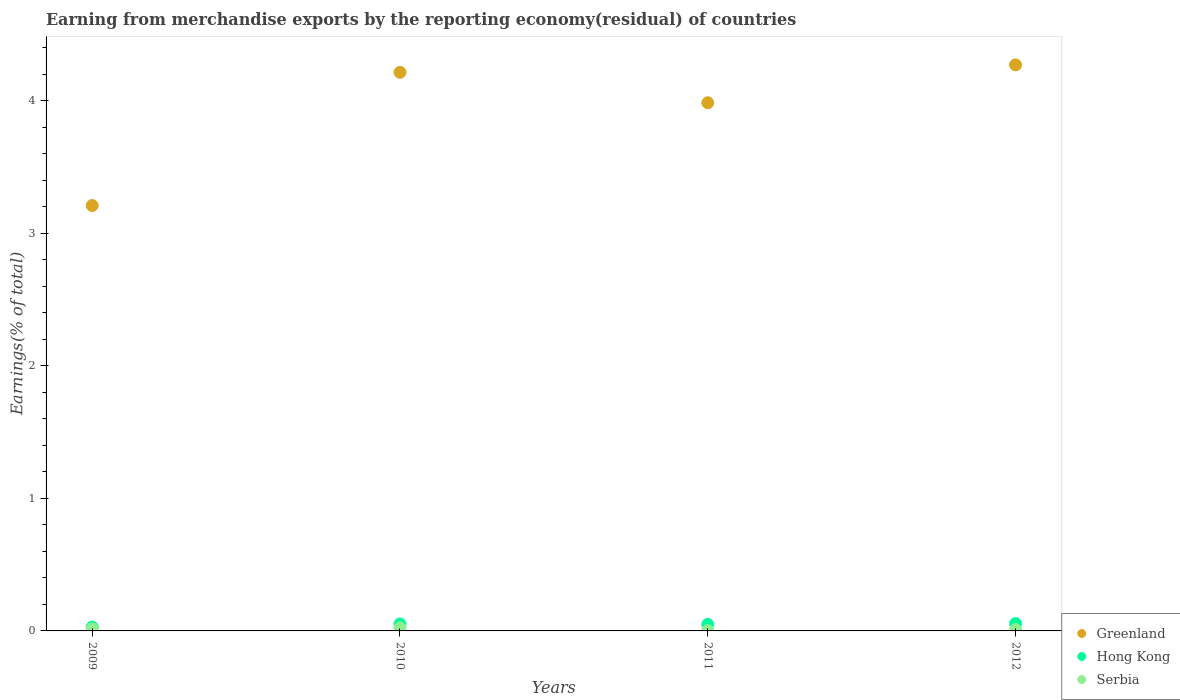How many different coloured dotlines are there?
Provide a short and direct response. 3. What is the percentage of amount earned from merchandise exports in Greenland in 2009?
Provide a short and direct response. 3.21. Across all years, what is the maximum percentage of amount earned from merchandise exports in Hong Kong?
Ensure brevity in your answer.  0.06. Across all years, what is the minimum percentage of amount earned from merchandise exports in Hong Kong?
Offer a terse response. 0.03. In which year was the percentage of amount earned from merchandise exports in Serbia minimum?
Your response must be concise. 2011. What is the total percentage of amount earned from merchandise exports in Serbia in the graph?
Ensure brevity in your answer.  0.05. What is the difference between the percentage of amount earned from merchandise exports in Greenland in 2010 and that in 2011?
Make the answer very short. 0.23. What is the difference between the percentage of amount earned from merchandise exports in Greenland in 2009 and the percentage of amount earned from merchandise exports in Serbia in 2012?
Ensure brevity in your answer.  3.2. What is the average percentage of amount earned from merchandise exports in Hong Kong per year?
Your answer should be compact. 0.05. In the year 2010, what is the difference between the percentage of amount earned from merchandise exports in Hong Kong and percentage of amount earned from merchandise exports in Greenland?
Keep it short and to the point. -4.16. In how many years, is the percentage of amount earned from merchandise exports in Hong Kong greater than 3.8 %?
Provide a succinct answer. 0. What is the ratio of the percentage of amount earned from merchandise exports in Hong Kong in 2010 to that in 2011?
Give a very brief answer. 1.07. What is the difference between the highest and the second highest percentage of amount earned from merchandise exports in Hong Kong?
Your answer should be very brief. 0. What is the difference between the highest and the lowest percentage of amount earned from merchandise exports in Greenland?
Provide a short and direct response. 1.06. In how many years, is the percentage of amount earned from merchandise exports in Hong Kong greater than the average percentage of amount earned from merchandise exports in Hong Kong taken over all years?
Keep it short and to the point. 3. Is the percentage of amount earned from merchandise exports in Greenland strictly less than the percentage of amount earned from merchandise exports in Serbia over the years?
Ensure brevity in your answer.  No. How many dotlines are there?
Give a very brief answer. 3. How many years are there in the graph?
Your answer should be compact. 4. Where does the legend appear in the graph?
Provide a succinct answer. Bottom right. How many legend labels are there?
Ensure brevity in your answer.  3. How are the legend labels stacked?
Offer a terse response. Vertical. What is the title of the graph?
Offer a very short reply. Earning from merchandise exports by the reporting economy(residual) of countries. What is the label or title of the Y-axis?
Provide a succinct answer. Earnings(% of total). What is the Earnings(% of total) of Greenland in 2009?
Your answer should be very brief. 3.21. What is the Earnings(% of total) in Hong Kong in 2009?
Make the answer very short. 0.03. What is the Earnings(% of total) in Serbia in 2009?
Your answer should be compact. 0.02. What is the Earnings(% of total) of Greenland in 2010?
Provide a succinct answer. 4.21. What is the Earnings(% of total) of Hong Kong in 2010?
Your answer should be compact. 0.05. What is the Earnings(% of total) in Serbia in 2010?
Make the answer very short. 0.02. What is the Earnings(% of total) of Greenland in 2011?
Your answer should be very brief. 3.99. What is the Earnings(% of total) of Hong Kong in 2011?
Provide a short and direct response. 0.05. What is the Earnings(% of total) in Serbia in 2011?
Offer a very short reply. 0. What is the Earnings(% of total) in Greenland in 2012?
Keep it short and to the point. 4.27. What is the Earnings(% of total) of Hong Kong in 2012?
Provide a short and direct response. 0.06. What is the Earnings(% of total) in Serbia in 2012?
Provide a succinct answer. 0.01. Across all years, what is the maximum Earnings(% of total) in Greenland?
Your answer should be compact. 4.27. Across all years, what is the maximum Earnings(% of total) in Hong Kong?
Offer a very short reply. 0.06. Across all years, what is the maximum Earnings(% of total) of Serbia?
Keep it short and to the point. 0.02. Across all years, what is the minimum Earnings(% of total) of Greenland?
Your answer should be very brief. 3.21. Across all years, what is the minimum Earnings(% of total) in Hong Kong?
Offer a terse response. 0.03. Across all years, what is the minimum Earnings(% of total) in Serbia?
Keep it short and to the point. 0. What is the total Earnings(% of total) in Greenland in the graph?
Your response must be concise. 15.68. What is the total Earnings(% of total) in Hong Kong in the graph?
Make the answer very short. 0.19. What is the total Earnings(% of total) of Serbia in the graph?
Provide a short and direct response. 0.05. What is the difference between the Earnings(% of total) in Greenland in 2009 and that in 2010?
Give a very brief answer. -1. What is the difference between the Earnings(% of total) in Hong Kong in 2009 and that in 2010?
Make the answer very short. -0.02. What is the difference between the Earnings(% of total) in Serbia in 2009 and that in 2010?
Your answer should be very brief. -0.01. What is the difference between the Earnings(% of total) of Greenland in 2009 and that in 2011?
Your response must be concise. -0.78. What is the difference between the Earnings(% of total) of Hong Kong in 2009 and that in 2011?
Give a very brief answer. -0.02. What is the difference between the Earnings(% of total) of Serbia in 2009 and that in 2011?
Make the answer very short. 0.01. What is the difference between the Earnings(% of total) in Greenland in 2009 and that in 2012?
Your answer should be very brief. -1.06. What is the difference between the Earnings(% of total) of Hong Kong in 2009 and that in 2012?
Provide a short and direct response. -0.03. What is the difference between the Earnings(% of total) in Serbia in 2009 and that in 2012?
Ensure brevity in your answer.  0.01. What is the difference between the Earnings(% of total) in Greenland in 2010 and that in 2011?
Offer a terse response. 0.23. What is the difference between the Earnings(% of total) of Hong Kong in 2010 and that in 2011?
Ensure brevity in your answer.  0. What is the difference between the Earnings(% of total) of Serbia in 2010 and that in 2011?
Provide a short and direct response. 0.02. What is the difference between the Earnings(% of total) of Greenland in 2010 and that in 2012?
Make the answer very short. -0.06. What is the difference between the Earnings(% of total) in Hong Kong in 2010 and that in 2012?
Provide a succinct answer. -0. What is the difference between the Earnings(% of total) of Serbia in 2010 and that in 2012?
Keep it short and to the point. 0.01. What is the difference between the Earnings(% of total) in Greenland in 2011 and that in 2012?
Offer a terse response. -0.29. What is the difference between the Earnings(% of total) of Hong Kong in 2011 and that in 2012?
Provide a succinct answer. -0.01. What is the difference between the Earnings(% of total) in Serbia in 2011 and that in 2012?
Give a very brief answer. -0.01. What is the difference between the Earnings(% of total) of Greenland in 2009 and the Earnings(% of total) of Hong Kong in 2010?
Offer a very short reply. 3.16. What is the difference between the Earnings(% of total) in Greenland in 2009 and the Earnings(% of total) in Serbia in 2010?
Make the answer very short. 3.19. What is the difference between the Earnings(% of total) of Hong Kong in 2009 and the Earnings(% of total) of Serbia in 2010?
Keep it short and to the point. 0.01. What is the difference between the Earnings(% of total) in Greenland in 2009 and the Earnings(% of total) in Hong Kong in 2011?
Give a very brief answer. 3.16. What is the difference between the Earnings(% of total) of Greenland in 2009 and the Earnings(% of total) of Serbia in 2011?
Offer a terse response. 3.21. What is the difference between the Earnings(% of total) of Hong Kong in 2009 and the Earnings(% of total) of Serbia in 2011?
Ensure brevity in your answer.  0.03. What is the difference between the Earnings(% of total) of Greenland in 2009 and the Earnings(% of total) of Hong Kong in 2012?
Your answer should be compact. 3.15. What is the difference between the Earnings(% of total) in Greenland in 2009 and the Earnings(% of total) in Serbia in 2012?
Give a very brief answer. 3.2. What is the difference between the Earnings(% of total) of Hong Kong in 2009 and the Earnings(% of total) of Serbia in 2012?
Give a very brief answer. 0.02. What is the difference between the Earnings(% of total) of Greenland in 2010 and the Earnings(% of total) of Hong Kong in 2011?
Your answer should be very brief. 4.17. What is the difference between the Earnings(% of total) of Greenland in 2010 and the Earnings(% of total) of Serbia in 2011?
Your answer should be very brief. 4.21. What is the difference between the Earnings(% of total) in Hong Kong in 2010 and the Earnings(% of total) in Serbia in 2011?
Make the answer very short. 0.05. What is the difference between the Earnings(% of total) of Greenland in 2010 and the Earnings(% of total) of Hong Kong in 2012?
Offer a terse response. 4.16. What is the difference between the Earnings(% of total) in Greenland in 2010 and the Earnings(% of total) in Serbia in 2012?
Provide a short and direct response. 4.2. What is the difference between the Earnings(% of total) of Hong Kong in 2010 and the Earnings(% of total) of Serbia in 2012?
Your answer should be compact. 0.04. What is the difference between the Earnings(% of total) of Greenland in 2011 and the Earnings(% of total) of Hong Kong in 2012?
Offer a terse response. 3.93. What is the difference between the Earnings(% of total) in Greenland in 2011 and the Earnings(% of total) in Serbia in 2012?
Provide a short and direct response. 3.97. What is the difference between the Earnings(% of total) of Hong Kong in 2011 and the Earnings(% of total) of Serbia in 2012?
Provide a succinct answer. 0.04. What is the average Earnings(% of total) of Greenland per year?
Provide a succinct answer. 3.92. What is the average Earnings(% of total) in Hong Kong per year?
Provide a succinct answer. 0.05. What is the average Earnings(% of total) in Serbia per year?
Provide a short and direct response. 0.01. In the year 2009, what is the difference between the Earnings(% of total) of Greenland and Earnings(% of total) of Hong Kong?
Offer a very short reply. 3.18. In the year 2009, what is the difference between the Earnings(% of total) in Greenland and Earnings(% of total) in Serbia?
Provide a succinct answer. 3.19. In the year 2009, what is the difference between the Earnings(% of total) in Hong Kong and Earnings(% of total) in Serbia?
Provide a succinct answer. 0.01. In the year 2010, what is the difference between the Earnings(% of total) in Greenland and Earnings(% of total) in Hong Kong?
Your answer should be compact. 4.16. In the year 2010, what is the difference between the Earnings(% of total) in Greenland and Earnings(% of total) in Serbia?
Provide a short and direct response. 4.19. In the year 2010, what is the difference between the Earnings(% of total) in Hong Kong and Earnings(% of total) in Serbia?
Provide a short and direct response. 0.03. In the year 2011, what is the difference between the Earnings(% of total) in Greenland and Earnings(% of total) in Hong Kong?
Your answer should be very brief. 3.94. In the year 2011, what is the difference between the Earnings(% of total) in Greenland and Earnings(% of total) in Serbia?
Ensure brevity in your answer.  3.98. In the year 2011, what is the difference between the Earnings(% of total) of Hong Kong and Earnings(% of total) of Serbia?
Make the answer very short. 0.05. In the year 2012, what is the difference between the Earnings(% of total) of Greenland and Earnings(% of total) of Hong Kong?
Make the answer very short. 4.22. In the year 2012, what is the difference between the Earnings(% of total) of Greenland and Earnings(% of total) of Serbia?
Keep it short and to the point. 4.26. In the year 2012, what is the difference between the Earnings(% of total) of Hong Kong and Earnings(% of total) of Serbia?
Offer a terse response. 0.05. What is the ratio of the Earnings(% of total) in Greenland in 2009 to that in 2010?
Your response must be concise. 0.76. What is the ratio of the Earnings(% of total) in Hong Kong in 2009 to that in 2010?
Provide a short and direct response. 0.55. What is the ratio of the Earnings(% of total) in Serbia in 2009 to that in 2010?
Your answer should be compact. 0.69. What is the ratio of the Earnings(% of total) in Greenland in 2009 to that in 2011?
Keep it short and to the point. 0.81. What is the ratio of the Earnings(% of total) in Hong Kong in 2009 to that in 2011?
Provide a short and direct response. 0.59. What is the ratio of the Earnings(% of total) of Serbia in 2009 to that in 2011?
Offer a terse response. 5.94. What is the ratio of the Earnings(% of total) of Greenland in 2009 to that in 2012?
Provide a succinct answer. 0.75. What is the ratio of the Earnings(% of total) of Hong Kong in 2009 to that in 2012?
Provide a succinct answer. 0.52. What is the ratio of the Earnings(% of total) in Serbia in 2009 to that in 2012?
Your answer should be compact. 1.52. What is the ratio of the Earnings(% of total) in Greenland in 2010 to that in 2011?
Make the answer very short. 1.06. What is the ratio of the Earnings(% of total) in Hong Kong in 2010 to that in 2011?
Your answer should be very brief. 1.07. What is the ratio of the Earnings(% of total) in Serbia in 2010 to that in 2011?
Your response must be concise. 8.61. What is the ratio of the Earnings(% of total) in Hong Kong in 2010 to that in 2012?
Your answer should be very brief. 0.95. What is the ratio of the Earnings(% of total) of Serbia in 2010 to that in 2012?
Your answer should be compact. 2.21. What is the ratio of the Earnings(% of total) in Greenland in 2011 to that in 2012?
Your response must be concise. 0.93. What is the ratio of the Earnings(% of total) of Hong Kong in 2011 to that in 2012?
Provide a short and direct response. 0.88. What is the ratio of the Earnings(% of total) of Serbia in 2011 to that in 2012?
Your answer should be compact. 0.26. What is the difference between the highest and the second highest Earnings(% of total) of Greenland?
Your response must be concise. 0.06. What is the difference between the highest and the second highest Earnings(% of total) in Hong Kong?
Your answer should be very brief. 0. What is the difference between the highest and the second highest Earnings(% of total) of Serbia?
Make the answer very short. 0.01. What is the difference between the highest and the lowest Earnings(% of total) of Greenland?
Your answer should be compact. 1.06. What is the difference between the highest and the lowest Earnings(% of total) of Hong Kong?
Ensure brevity in your answer.  0.03. What is the difference between the highest and the lowest Earnings(% of total) in Serbia?
Offer a very short reply. 0.02. 